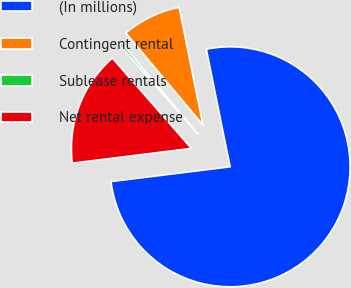Convert chart. <chart><loc_0><loc_0><loc_500><loc_500><pie_chart><fcel>(In millions)<fcel>Contingent rental<fcel>Sublease rentals<fcel>Net rental expense<nl><fcel>76.21%<fcel>7.93%<fcel>0.34%<fcel>15.52%<nl></chart> 